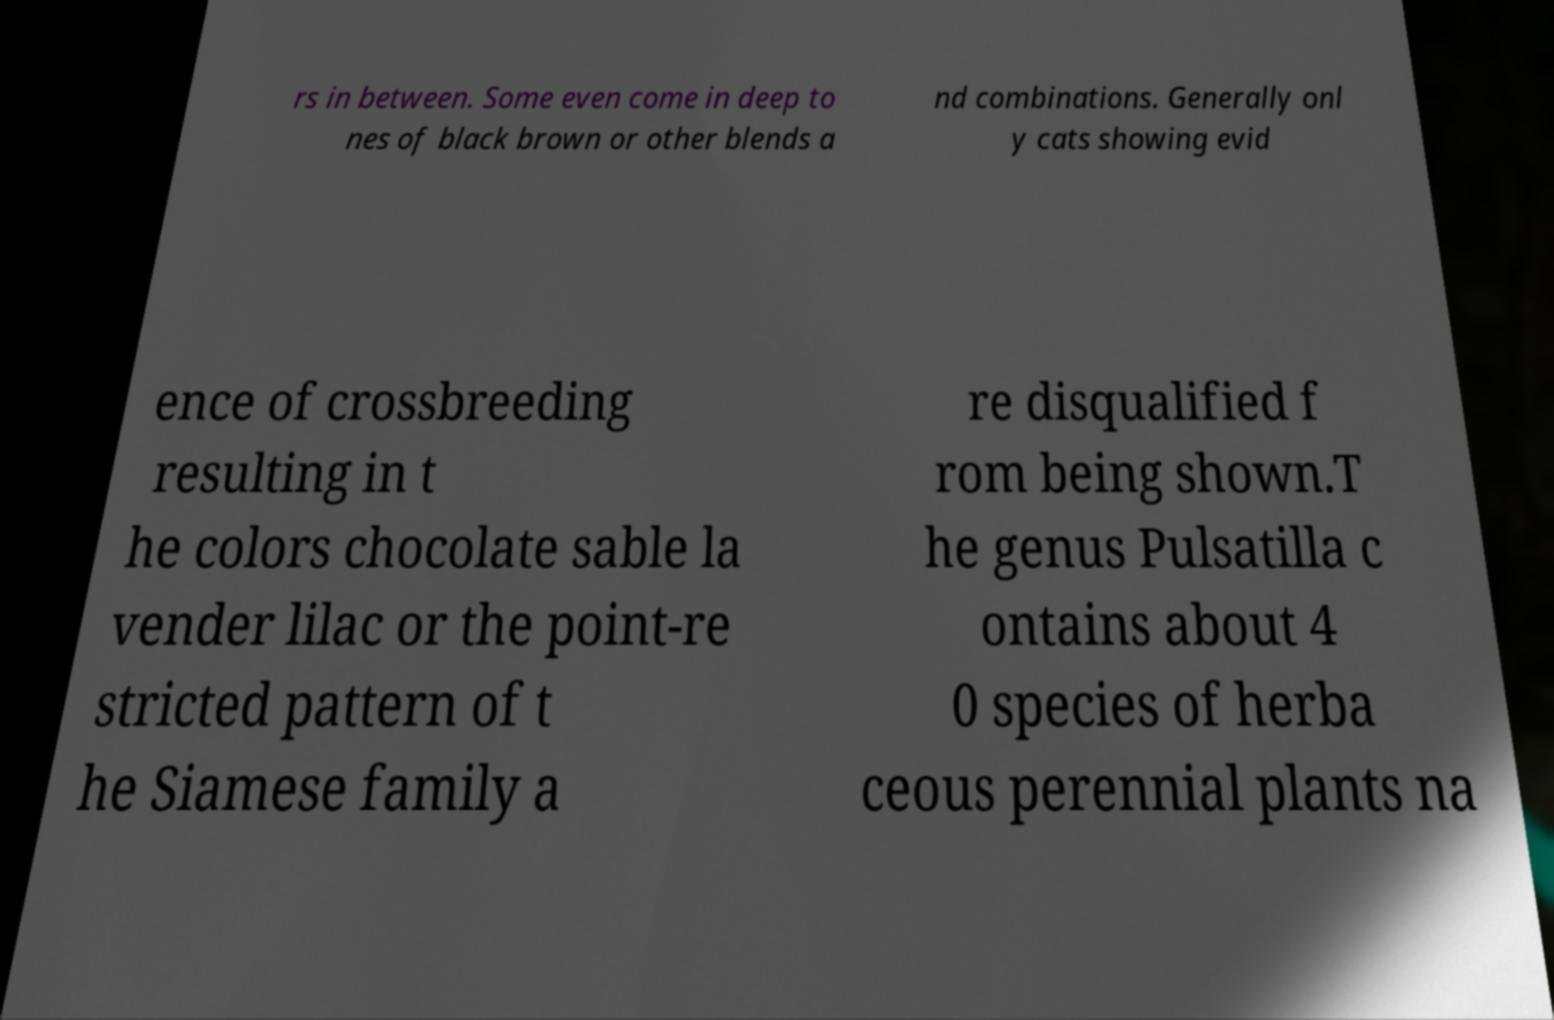What messages or text are displayed in this image? I need them in a readable, typed format. rs in between. Some even come in deep to nes of black brown or other blends a nd combinations. Generally onl y cats showing evid ence of crossbreeding resulting in t he colors chocolate sable la vender lilac or the point-re stricted pattern of t he Siamese family a re disqualified f rom being shown.T he genus Pulsatilla c ontains about 4 0 species of herba ceous perennial plants na 